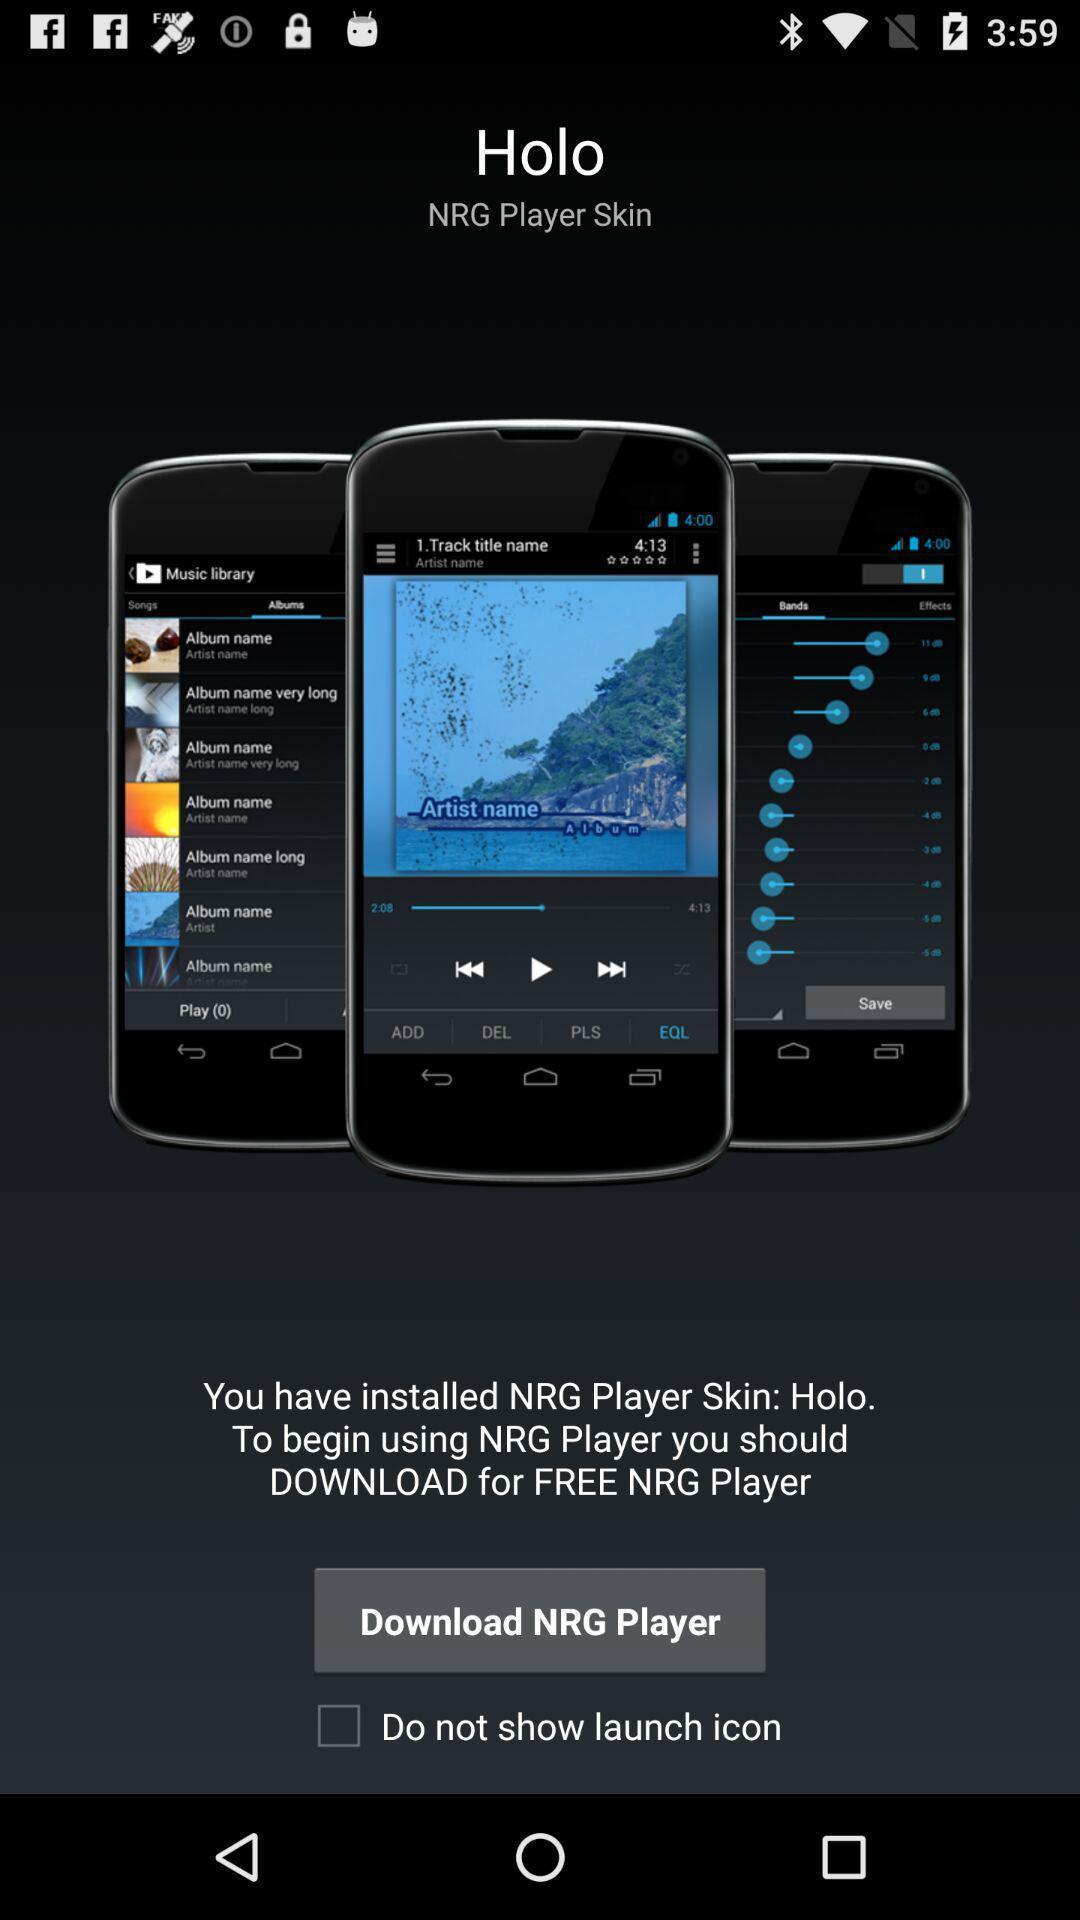Provide a description of this screenshot. Welcome page. 